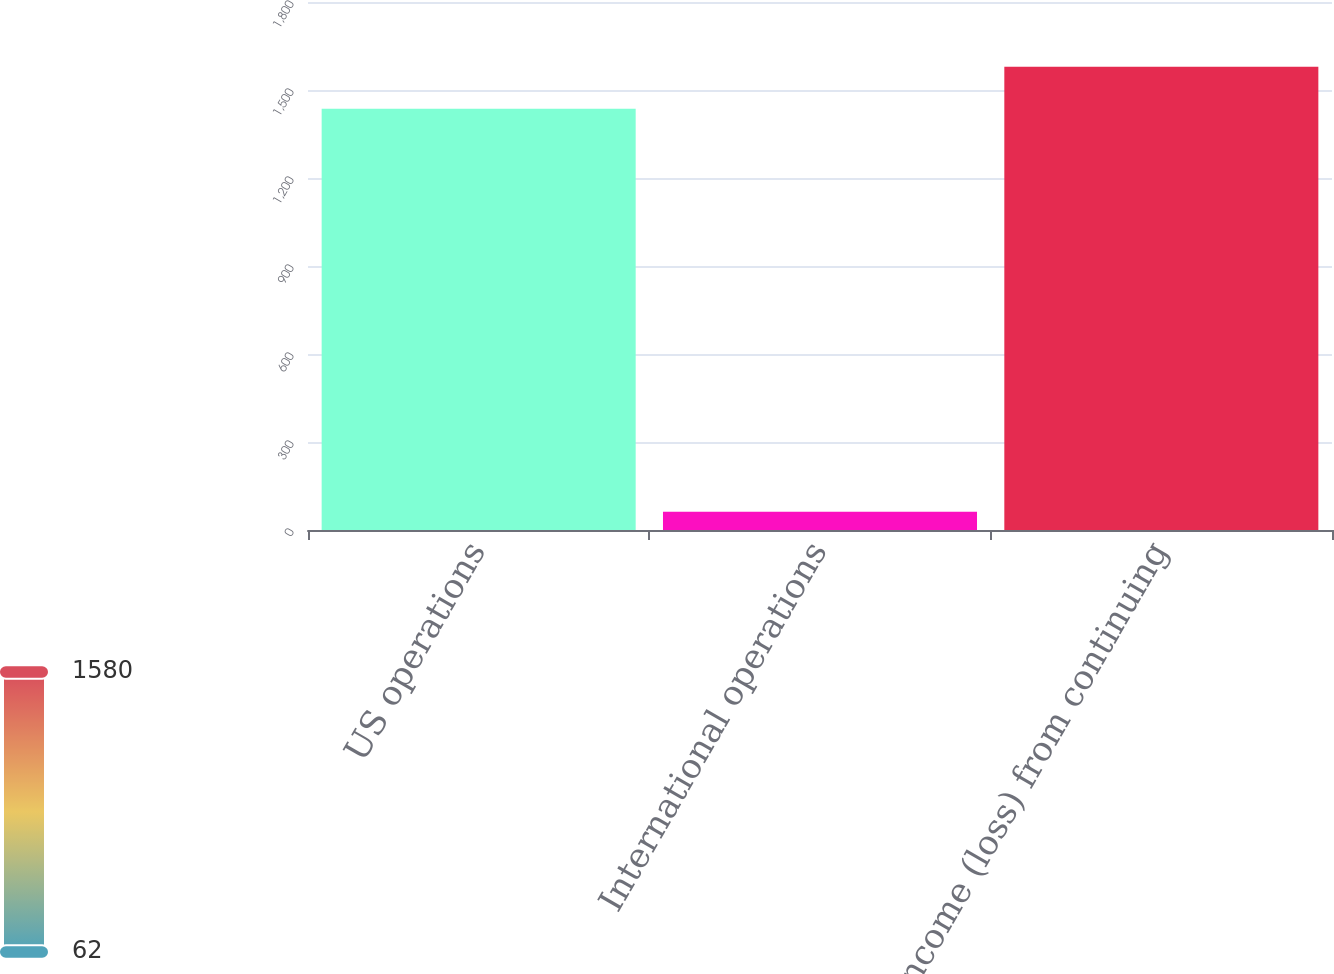Convert chart to OTSL. <chart><loc_0><loc_0><loc_500><loc_500><bar_chart><fcel>US operations<fcel>International operations<fcel>Income (loss) from continuing<nl><fcel>1436<fcel>62<fcel>1579.6<nl></chart> 